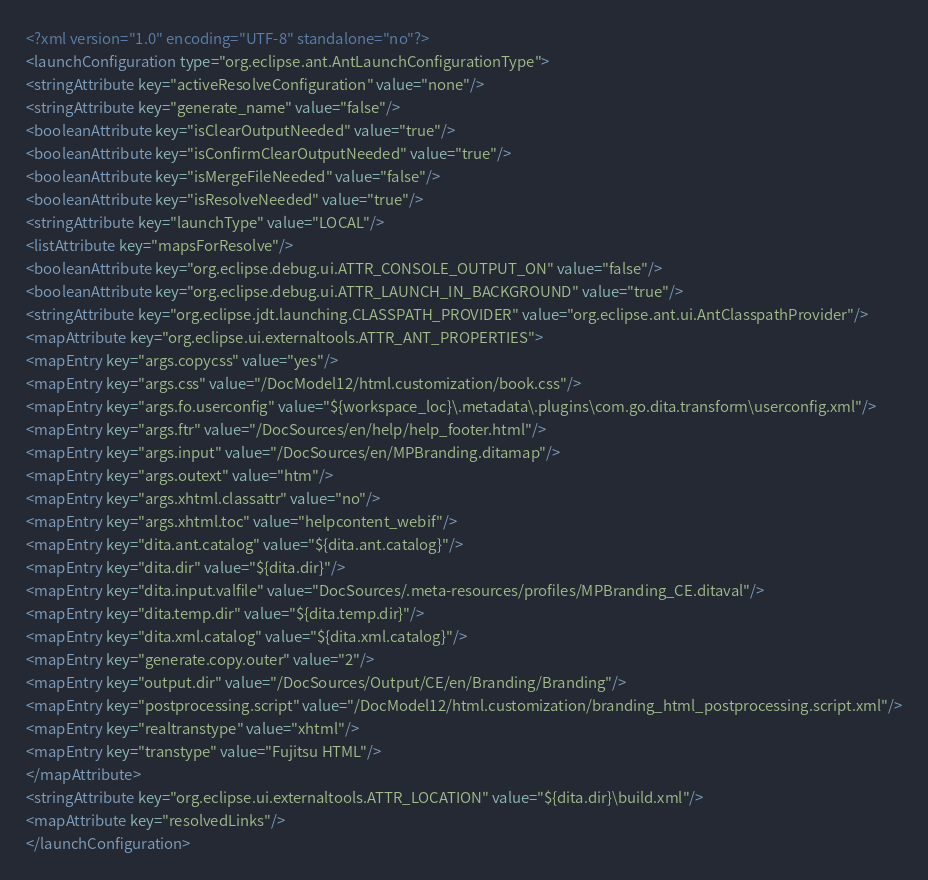<code> <loc_0><loc_0><loc_500><loc_500><_XML_><?xml version="1.0" encoding="UTF-8" standalone="no"?>
<launchConfiguration type="org.eclipse.ant.AntLaunchConfigurationType">
<stringAttribute key="activeResolveConfiguration" value="none"/>
<stringAttribute key="generate_name" value="false"/>
<booleanAttribute key="isClearOutputNeeded" value="true"/>
<booleanAttribute key="isConfirmClearOutputNeeded" value="true"/>
<booleanAttribute key="isMergeFileNeeded" value="false"/>
<booleanAttribute key="isResolveNeeded" value="true"/>
<stringAttribute key="launchType" value="LOCAL"/>
<listAttribute key="mapsForResolve"/>
<booleanAttribute key="org.eclipse.debug.ui.ATTR_CONSOLE_OUTPUT_ON" value="false"/>
<booleanAttribute key="org.eclipse.debug.ui.ATTR_LAUNCH_IN_BACKGROUND" value="true"/>
<stringAttribute key="org.eclipse.jdt.launching.CLASSPATH_PROVIDER" value="org.eclipse.ant.ui.AntClasspathProvider"/>
<mapAttribute key="org.eclipse.ui.externaltools.ATTR_ANT_PROPERTIES">
<mapEntry key="args.copycss" value="yes"/>
<mapEntry key="args.css" value="/DocModel12/html.customization/book.css"/>
<mapEntry key="args.fo.userconfig" value="${workspace_loc}\.metadata\.plugins\com.go.dita.transform\userconfig.xml"/>
<mapEntry key="args.ftr" value="/DocSources/en/help/help_footer.html"/>
<mapEntry key="args.input" value="/DocSources/en/MPBranding.ditamap"/>
<mapEntry key="args.outext" value="htm"/>
<mapEntry key="args.xhtml.classattr" value="no"/>
<mapEntry key="args.xhtml.toc" value="helpcontent_webif"/>
<mapEntry key="dita.ant.catalog" value="${dita.ant.catalog}"/>
<mapEntry key="dita.dir" value="${dita.dir}"/>
<mapEntry key="dita.input.valfile" value="DocSources/.meta-resources/profiles/MPBranding_CE.ditaval"/>
<mapEntry key="dita.temp.dir" value="${dita.temp.dir}"/>
<mapEntry key="dita.xml.catalog" value="${dita.xml.catalog}"/>
<mapEntry key="generate.copy.outer" value="2"/>
<mapEntry key="output.dir" value="/DocSources/Output/CE/en/Branding/Branding"/>
<mapEntry key="postprocessing.script" value="/DocModel12/html.customization/branding_html_postprocessing.script.xml"/>
<mapEntry key="realtranstype" value="xhtml"/>
<mapEntry key="transtype" value="Fujitsu HTML"/>
</mapAttribute>
<stringAttribute key="org.eclipse.ui.externaltools.ATTR_LOCATION" value="${dita.dir}\build.xml"/>
<mapAttribute key="resolvedLinks"/>
</launchConfiguration>
</code> 